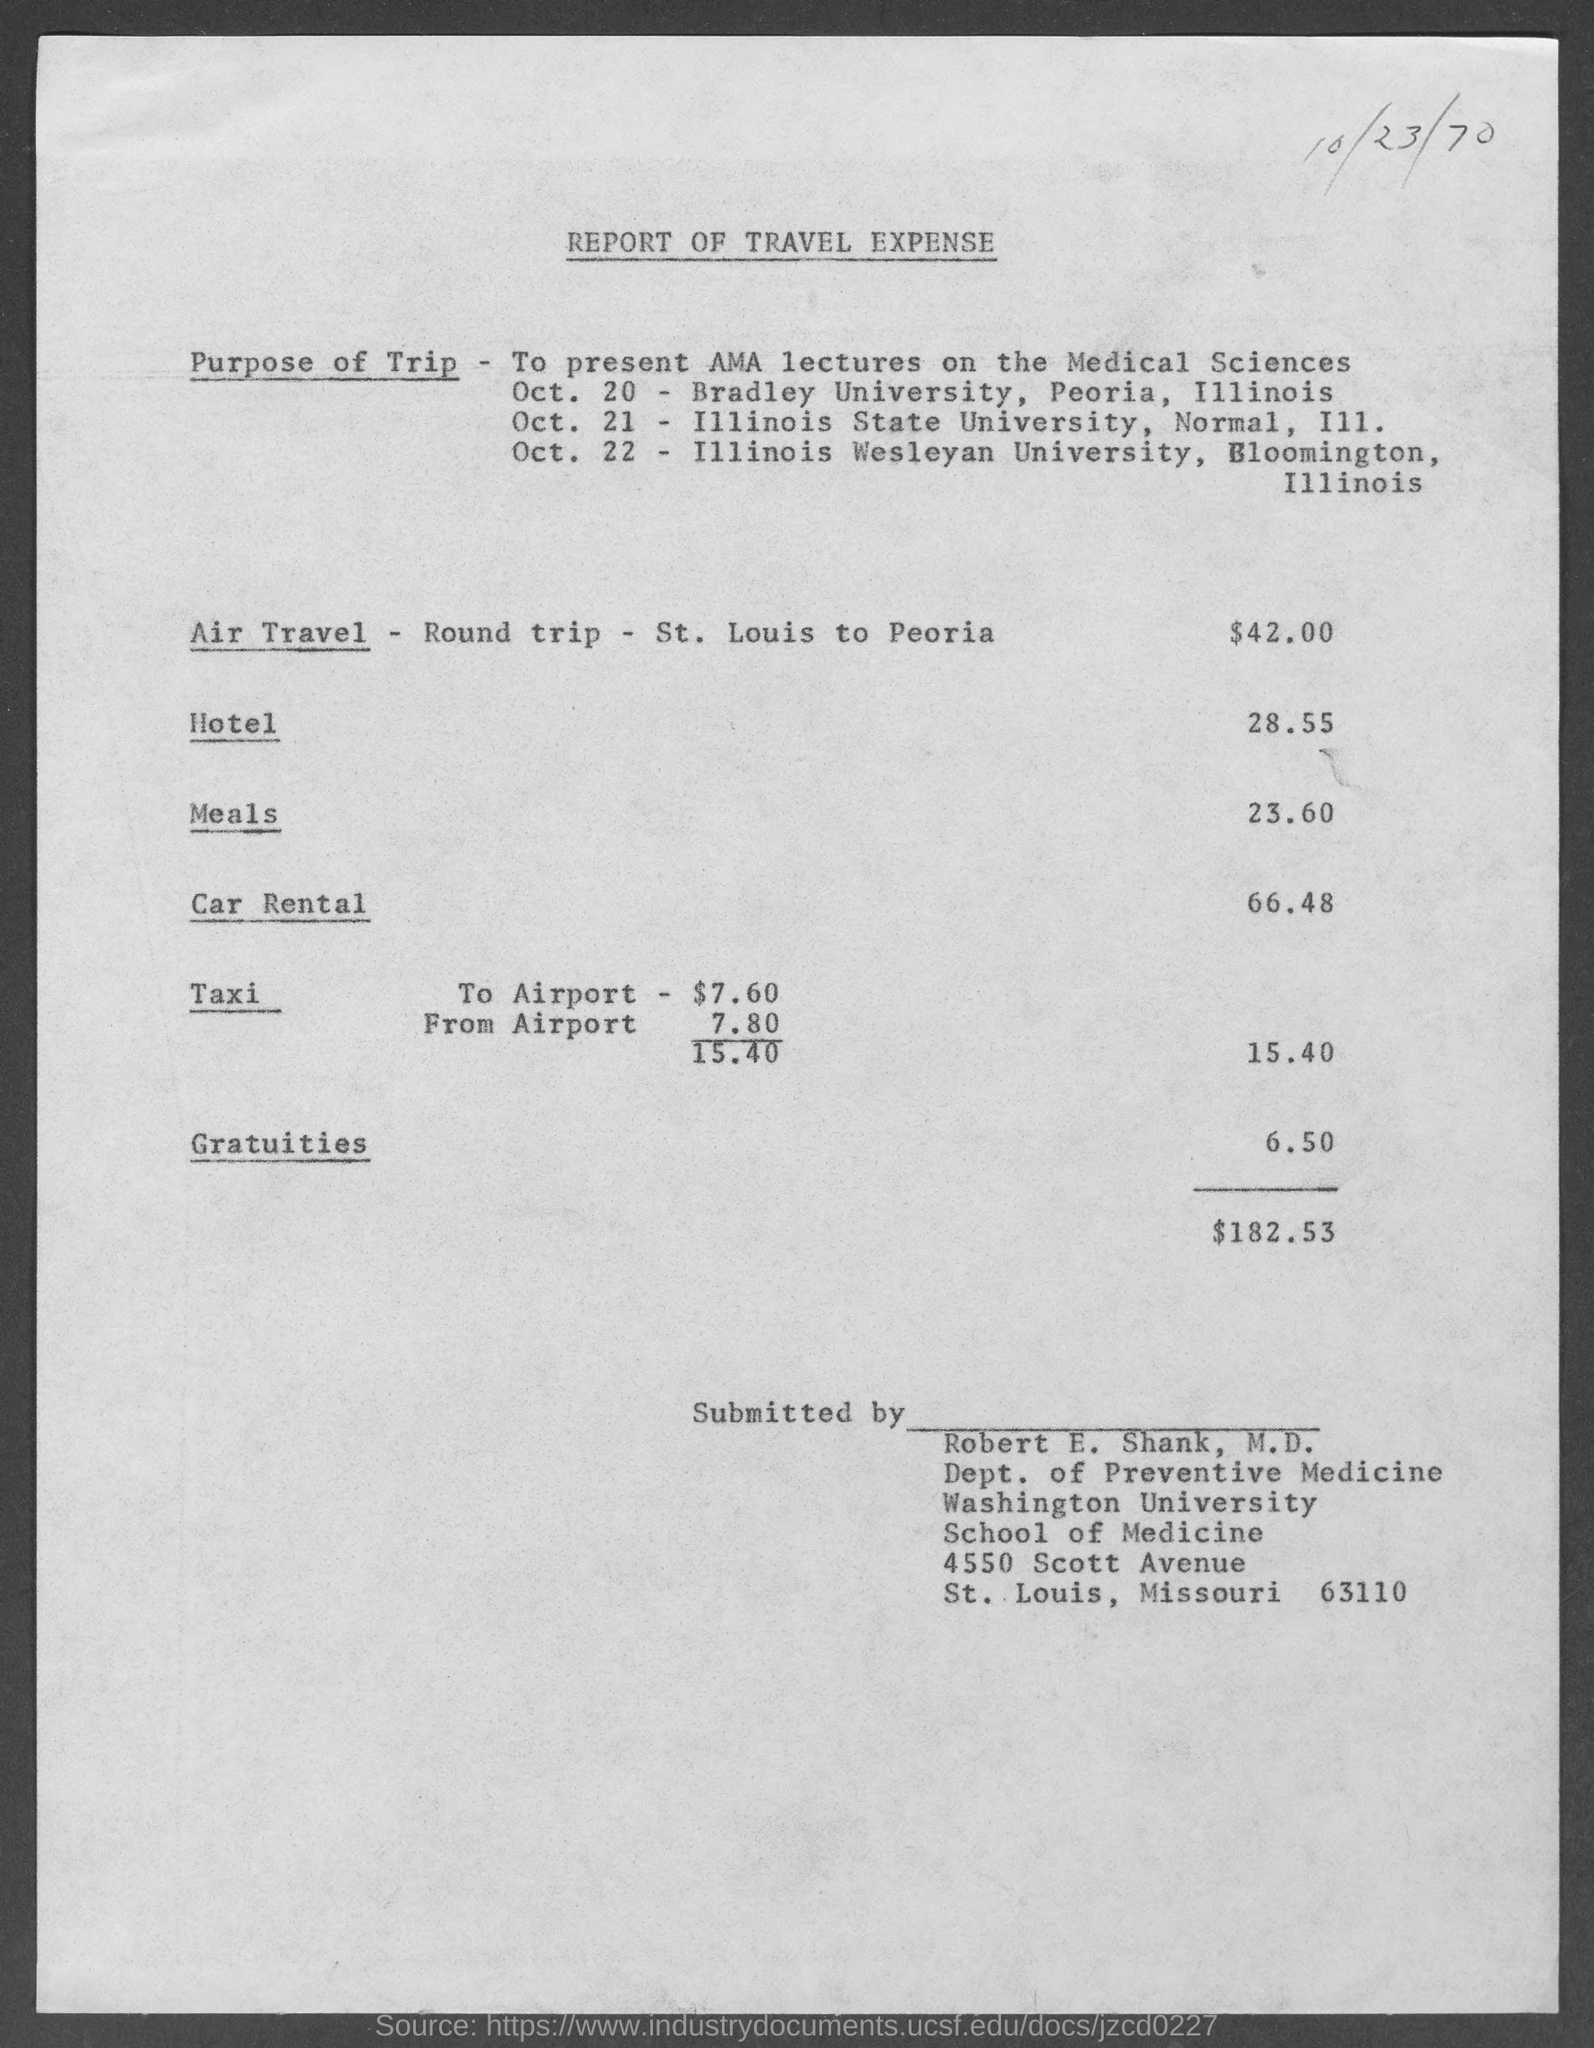What is the purpose of the trip mentioned in the given report ?
Your answer should be very brief. TO PRESENT AMA LECTURES ON THE MEDICAL SCIENCES. What  is the amount for air travel -round trip- st. louis to peoria mentioned in the given report ?
Give a very brief answer. 42.00. What are the expenses for the hotel as mentioned in the given report ?
Your answer should be very brief. 28.55. What are the expenses for meals as mentioned in the given report ?
Offer a terse response. 23.60. What is the amount for car rental as mentioned in the given report ?
Your answer should be compact. 66 48. What are the expenses for taxi as mentioned in the given report ?
Provide a short and direct response. 15.40. What is the amount for gratuities mentioned in the given report ?
Give a very brief answer. 6.50. What is the amount of total expenses mentioned in the given report ?
Your response must be concise. $182 53. What is the date mentioned in the given report ?
Make the answer very short. 10/23/70. Who submitted this repot?
Your response must be concise. Robert E. Shank. 